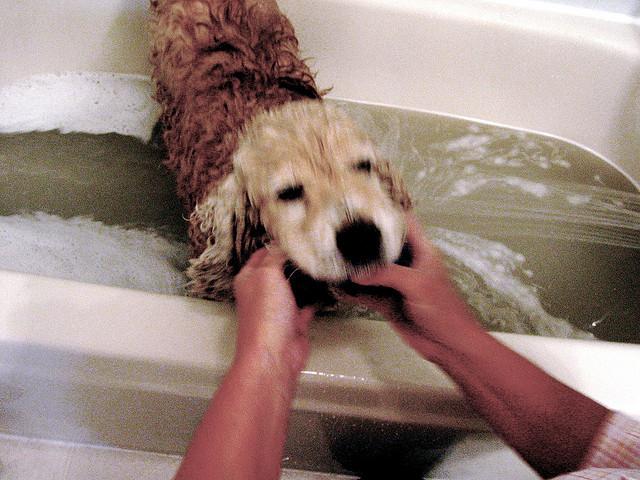What is in the picture?
Write a very short answer. Dog. Does the animal in the picture have a name?
Write a very short answer. Yes. Is this dog getting a bath?
Write a very short answer. Yes. 